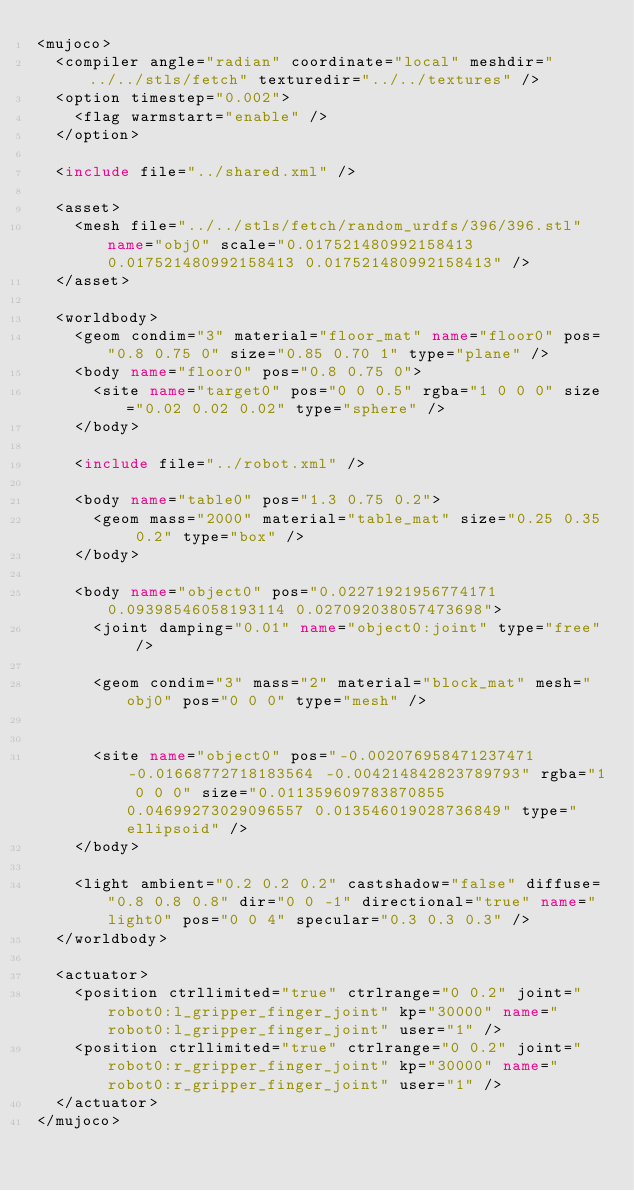<code> <loc_0><loc_0><loc_500><loc_500><_XML_><mujoco>
	<compiler angle="radian" coordinate="local" meshdir="../../stls/fetch" texturedir="../../textures" />
	<option timestep="0.002">
		<flag warmstart="enable" />
	</option>

	<include file="../shared.xml" />

	<asset>
		<mesh file="../../stls/fetch/random_urdfs/396/396.stl" name="obj0" scale="0.017521480992158413 0.017521480992158413 0.017521480992158413" />
	</asset>

	<worldbody>
		<geom condim="3" material="floor_mat" name="floor0" pos="0.8 0.75 0" size="0.85 0.70 1" type="plane" />
		<body name="floor0" pos="0.8 0.75 0">
			<site name="target0" pos="0 0 0.5" rgba="1 0 0 0" size="0.02 0.02 0.02" type="sphere" />
		</body>

		<include file="../robot.xml" />

		<body name="table0" pos="1.3 0.75 0.2">
			<geom mass="2000" material="table_mat" size="0.25 0.35 0.2" type="box" />
		</body>

		<body name="object0" pos="0.02271921956774171 0.09398546058193114 0.027092038057473698">
			<joint damping="0.01" name="object0:joint" type="free" />
			
			<geom condim="3" mass="2" material="block_mat" mesh="obj0" pos="0 0 0" type="mesh" />
			
			
			<site name="object0" pos="-0.002076958471237471 -0.01668772718183564 -0.004214842823789793" rgba="1 0 0 0" size="0.011359609783870855 0.04699273029096557 0.013546019028736849" type="ellipsoid" />
		</body>

		<light ambient="0.2 0.2 0.2" castshadow="false" diffuse="0.8 0.8 0.8" dir="0 0 -1" directional="true" name="light0" pos="0 0 4" specular="0.3 0.3 0.3" />
	</worldbody>

	<actuator>
		<position ctrllimited="true" ctrlrange="0 0.2" joint="robot0:l_gripper_finger_joint" kp="30000" name="robot0:l_gripper_finger_joint" user="1" />
		<position ctrllimited="true" ctrlrange="0 0.2" joint="robot0:r_gripper_finger_joint" kp="30000" name="robot0:r_gripper_finger_joint" user="1" />
	</actuator>
</mujoco></code> 